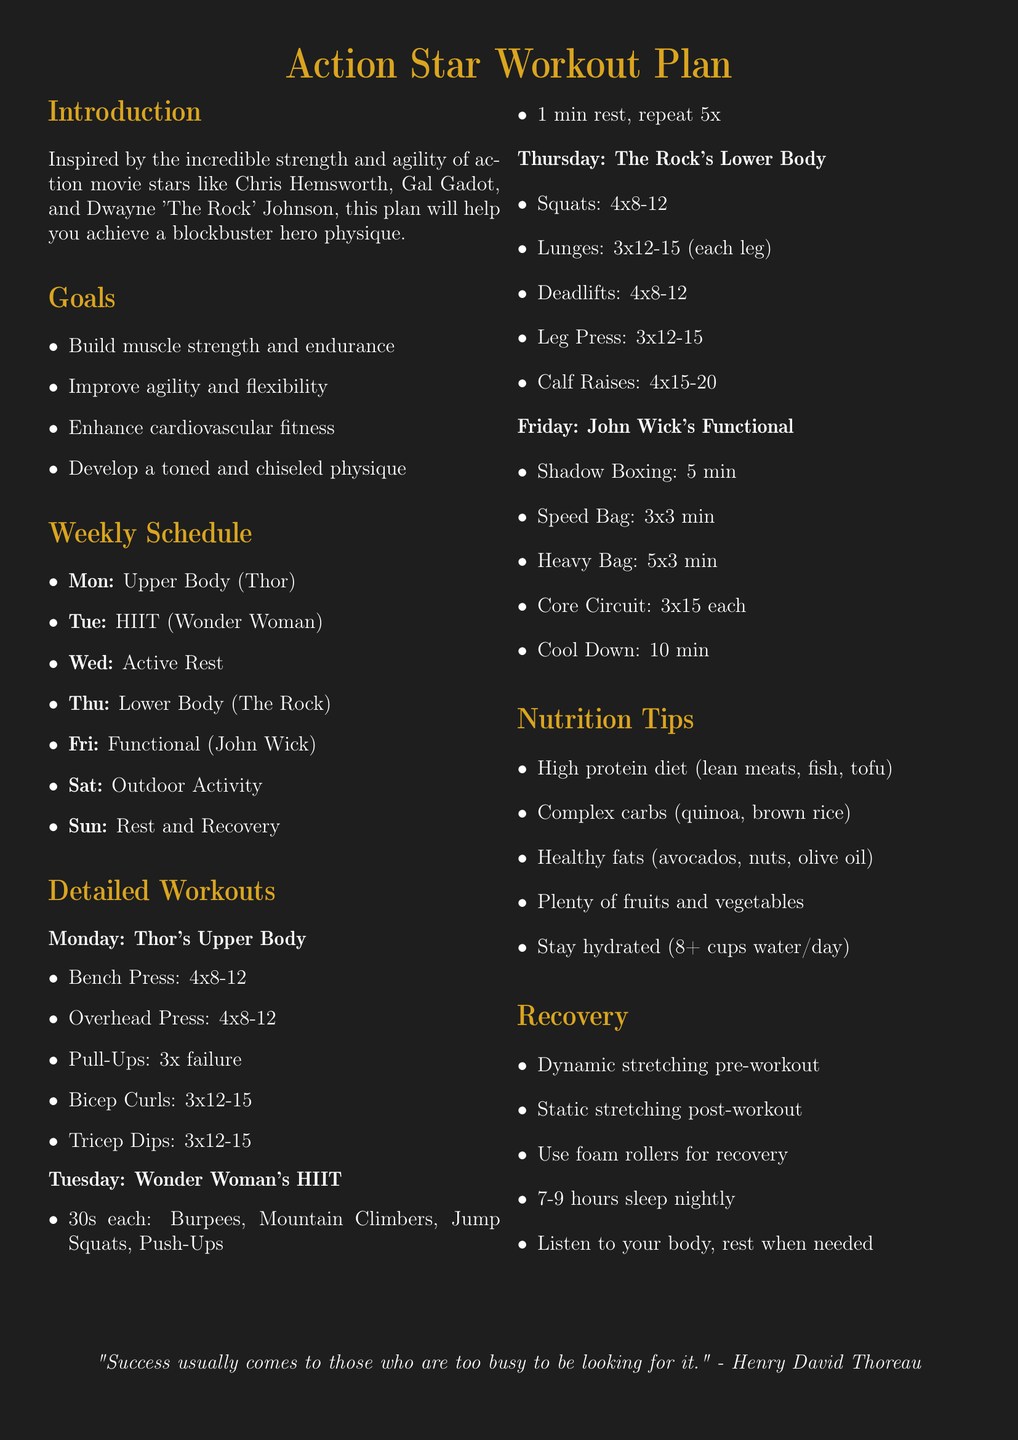What is the title of the workout plan? The title is prominently displayed at the top of the document, indicating the focus of the workout.
Answer: Action Star Workout Plan Who is associated with the Upper Body workout? The document lists a specific action star whose workout is being emulated for Upper Body day.
Answer: Thor How many times is HIIT performed each week? HIIT is specifically scheduled on one day of the week according to the provided routine.
Answer: Once What is the recommended protein source in the nutrition tips? The nutrition section suggests various sources of protein, highlighting those that are preferred for muscle building.
Answer: Lean meats How many exercises are included in John's Functional workout? The document lists a series of specific exercises to be performed on Functional day, which can be counted.
Answer: Five What is the suggested duration of sleep for recovery? The recovery section specifies a recommended sleep duration for optimal recovery and health.
Answer: 7-9 hours What type of stretching is advised pre-workout? The recovery section outlines different types of stretching to be performed at specific times related to workouts.
Answer: Dynamic stretching On which day is an outdoor activity recommended? The weekly schedule includes one day devoted to outdoor physical activities for variety and enjoyment.
Answer: Saturday 